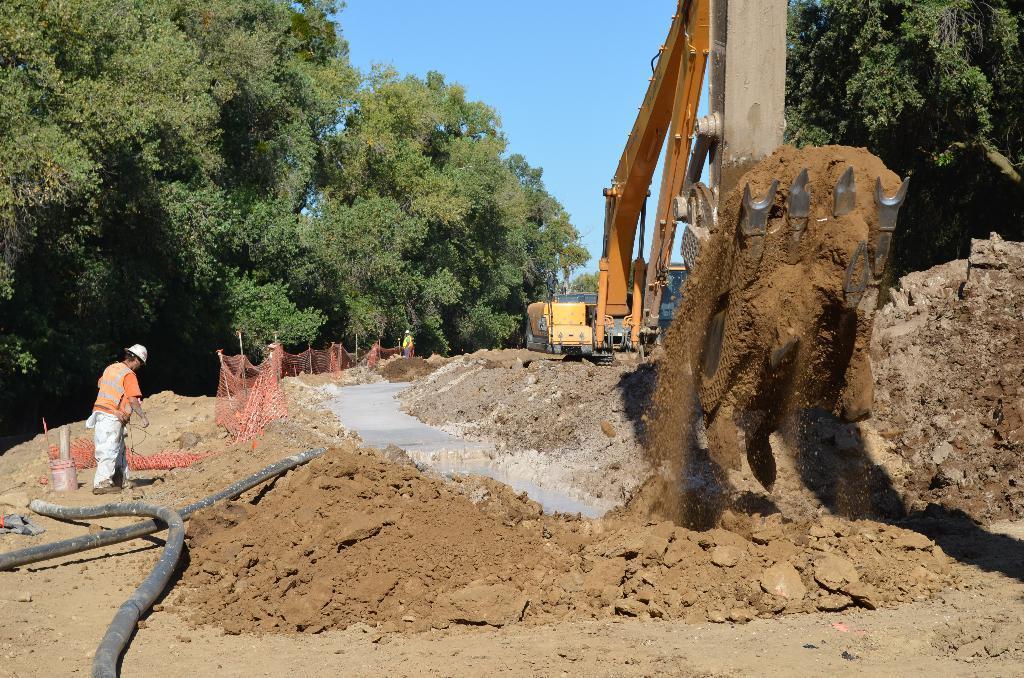Please provide a concise description of this image. In the image there is a crane, it is lifting a lot of soil and around the crane the land is covered with soil and on the left side there is a person, behind him there are few pipes, around the soil there are trees. 